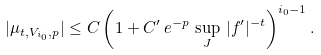<formula> <loc_0><loc_0><loc_500><loc_500>| \mu _ { t , V _ { i _ { 0 } } , p } | \leq C \left ( 1 + C ^ { \prime } \, e ^ { - p } \, \sup _ { J } \, | f ^ { \prime } | ^ { - t } \right ) ^ { i _ { 0 } - 1 } .</formula> 